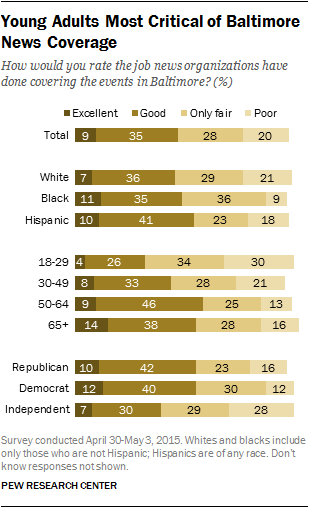List a handful of essential elements in this visual. The color brown is represented by the value of excellent. The minimum value of "poor" is 37, while the maximum value of "good" is also 37. 